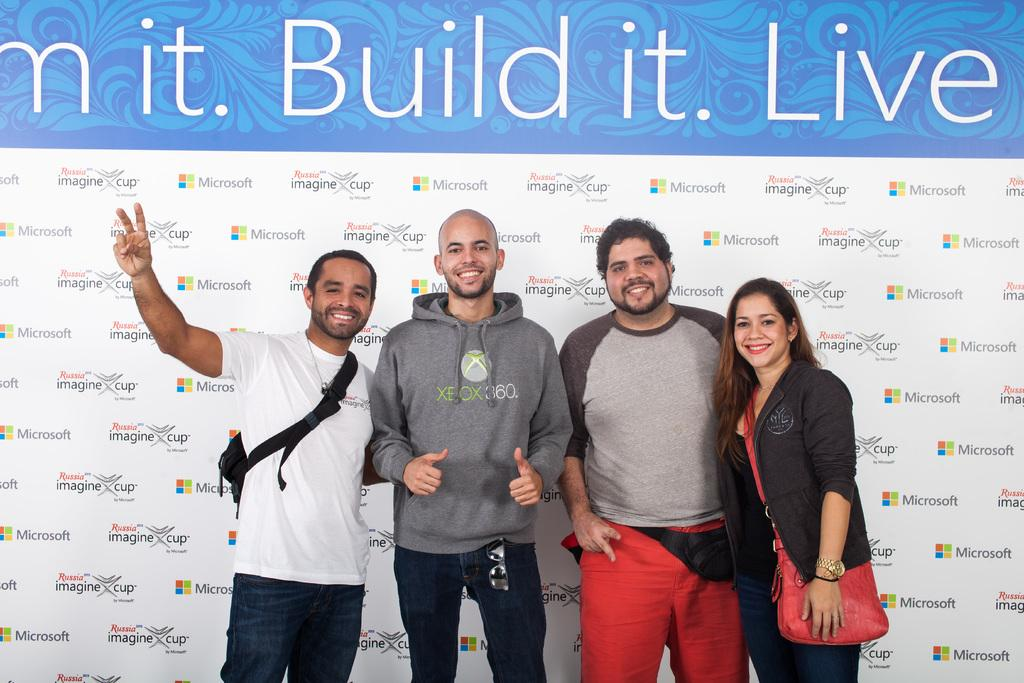What is the main subject of the image? The main subject of the image is a group of people in the center. Can you describe anything in the background of the image? Yes, there is a poster in the background of the image. What type of badge is being worn by the people in the image? There is no mention of badges in the image, so it cannot be determined if any are being worn. 